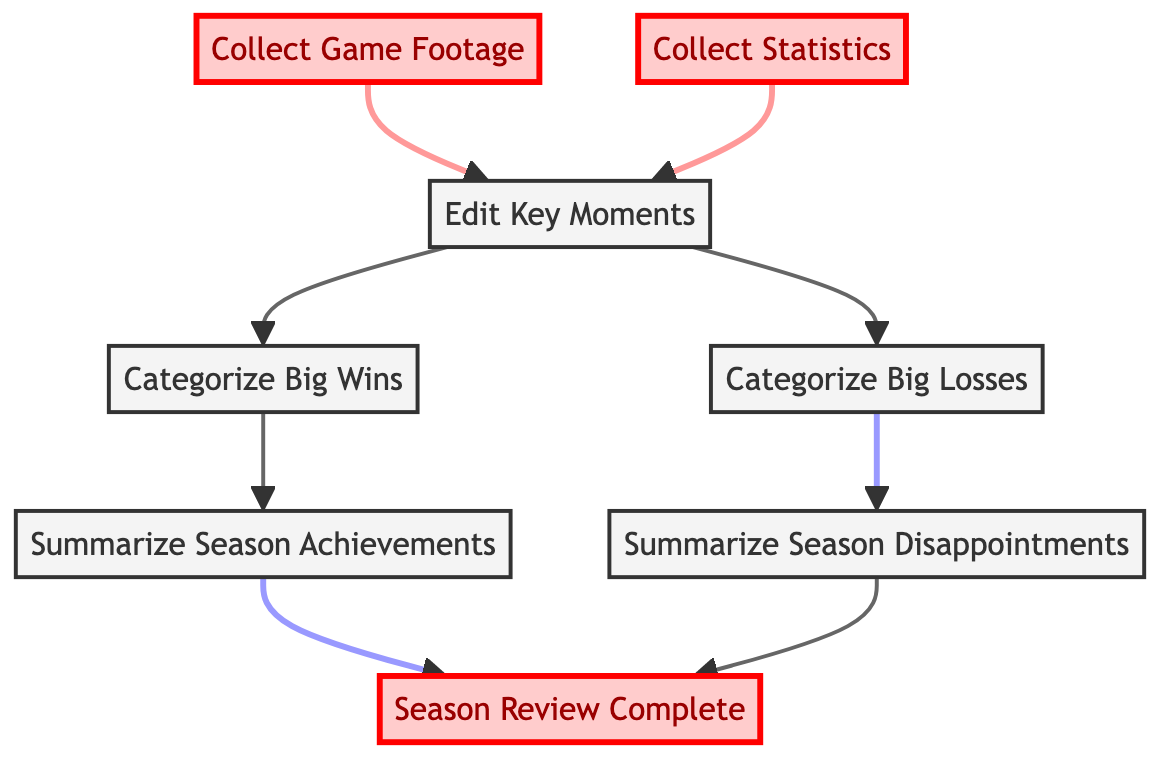What is the first step in the flowchart? The first step is "Collect Game Footage," which is at the bottom of the diagram.
Answer: Collect Game Footage How many steps are there in total? Counting all unique steps from the diagram provides a total of seven steps, from collecting footage and statistics to summarizing achievements and disappointments.
Answer: Seven Which steps directly follow "Edit Key Moments"? After "Edit Key Moments," the flowchart branches into two paths: "Categorize Big Wins" and "Categorize Big Losses."
Answer: Categorize Big Wins, Categorize Big Losses What happens after categorizing big losses? After categorizing big losses, the next step is to "Summarize Season Disappointments." This is a sequential flow from that node.
Answer: Summarize Season Disappointments What is the final output of this diagram? The last node in the diagram, which signifies the end of the process, is "Season Review Complete."
Answer: Season Review Complete How many categorization steps are present in the flow? There are two categorization steps in the flow, which are "Categorize Big Wins" and "Categorize Big Losses."
Answer: Two What are the two types of summaries at the top of the flowchart? The two types of summaries located at the top of the flowchart are "Summarize Season Achievements" and "Summarize Season Disappointments."
Answer: Summarize Season Achievements, Summarize Season Disappointments What is the relationship between collecting statistics and editing key moments? "Collect Statistics" is a prerequisite step that leads to "Edit Key Moments," meaning statistics must be collected first before editing key moments can occur.
Answer: Collect Statistics → Edit Key Moments Which elements are highlighted in the diagram? The highlighted elements are "Collect Game Footage," "Collect Statistics," and "Season Review Complete."
Answer: Collect Game Footage, Collect Statistics, Season Review Complete 